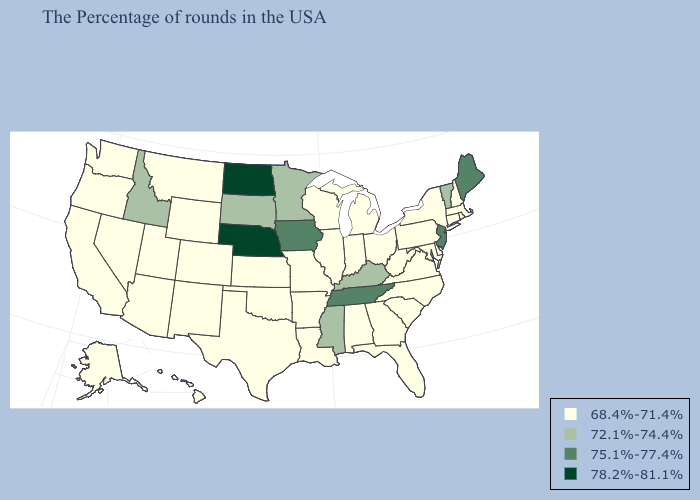What is the lowest value in the USA?
Write a very short answer. 68.4%-71.4%. What is the value of Alaska?
Keep it brief. 68.4%-71.4%. Among the states that border Missouri , which have the lowest value?
Concise answer only. Illinois, Arkansas, Kansas, Oklahoma. What is the value of North Dakota?
Concise answer only. 78.2%-81.1%. What is the lowest value in the South?
Give a very brief answer. 68.4%-71.4%. Name the states that have a value in the range 75.1%-77.4%?
Quick response, please. Maine, New Jersey, Tennessee, Iowa. Does the map have missing data?
Short answer required. No. What is the value of Iowa?
Quick response, please. 75.1%-77.4%. What is the highest value in the USA?
Answer briefly. 78.2%-81.1%. What is the value of Utah?
Concise answer only. 68.4%-71.4%. Name the states that have a value in the range 68.4%-71.4%?
Answer briefly. Massachusetts, Rhode Island, New Hampshire, Connecticut, New York, Delaware, Maryland, Pennsylvania, Virginia, North Carolina, South Carolina, West Virginia, Ohio, Florida, Georgia, Michigan, Indiana, Alabama, Wisconsin, Illinois, Louisiana, Missouri, Arkansas, Kansas, Oklahoma, Texas, Wyoming, Colorado, New Mexico, Utah, Montana, Arizona, Nevada, California, Washington, Oregon, Alaska, Hawaii. Among the states that border Arkansas , which have the highest value?
Answer briefly. Tennessee. Does Mississippi have a higher value than Minnesota?
Give a very brief answer. No. Does Vermont have the same value as South Dakota?
Be succinct. Yes. Name the states that have a value in the range 75.1%-77.4%?
Quick response, please. Maine, New Jersey, Tennessee, Iowa. 